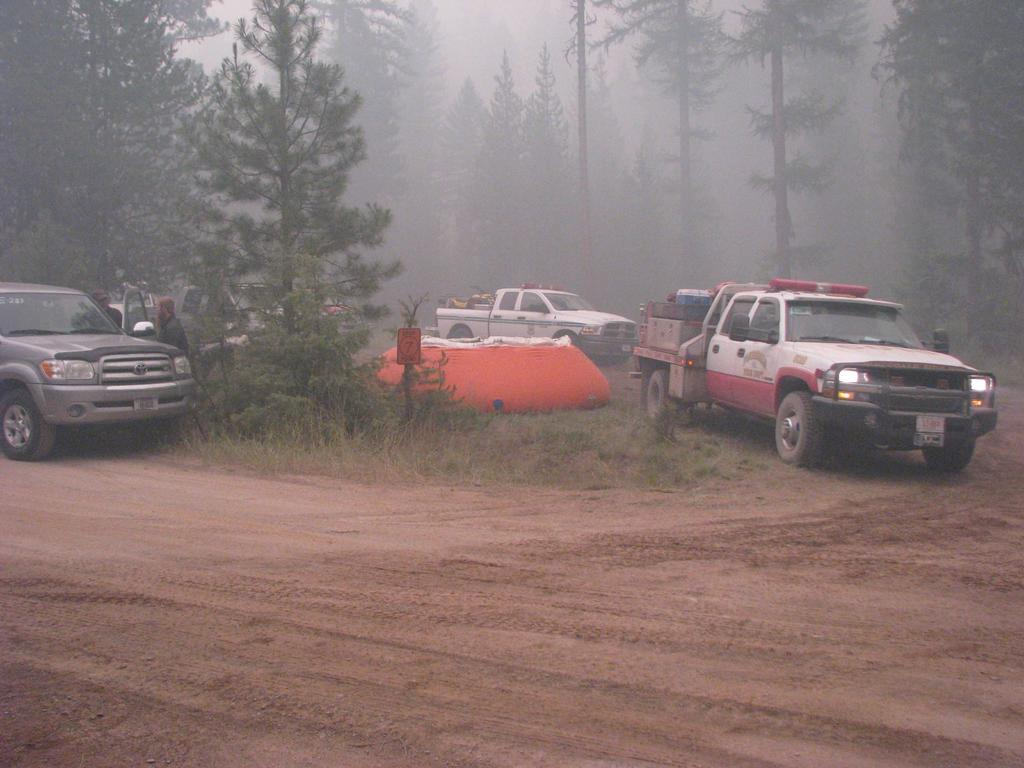What types of objects are present in the image? There are vehicles and an orange-colored object in the center of the image. Are there any living beings in the image? Yes, there are people in the image. What can be seen in the background of the image? There are trees and grass visible in the image. What is the weather condition in the image? There is fog in the image, which suggests a misty or cloudy condition. What type of wound can be seen on the woman in the image? There is no woman present in the image, and therefore no wound can be observed. What organization is responsible for the vehicles in the image? The image does not provide any information about the organization responsible for the vehicles. 